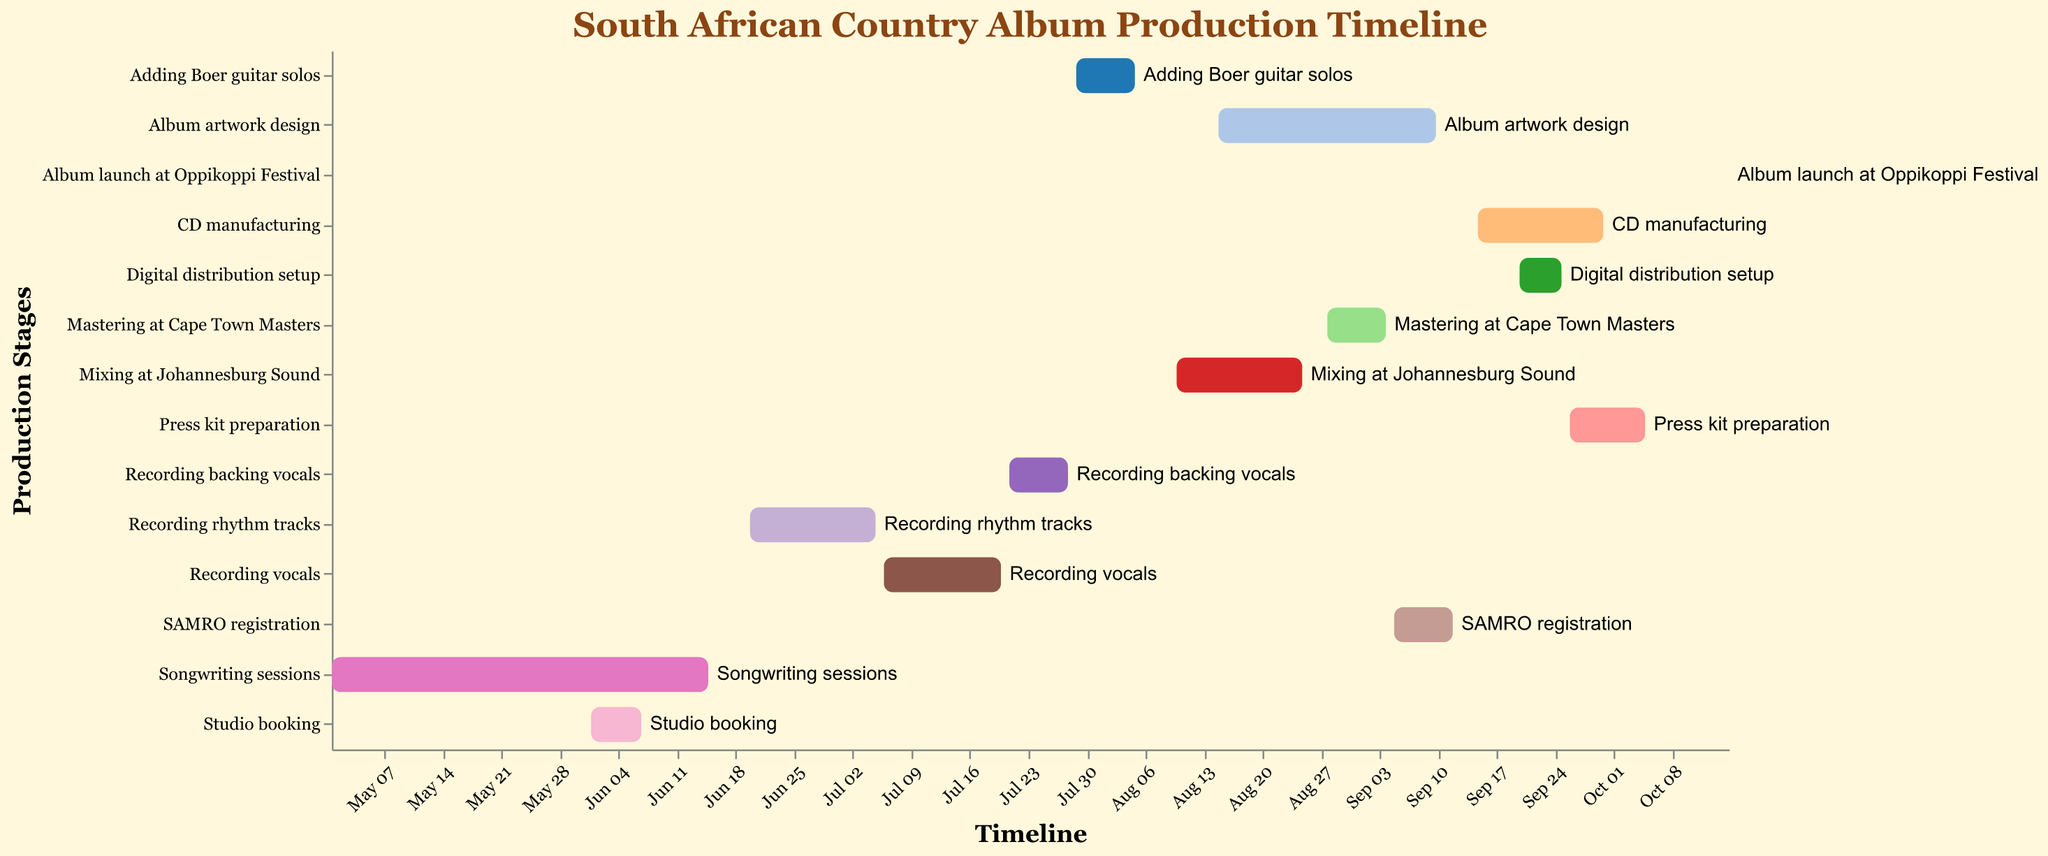What is the title of the Gantt Chart? The title of the chart is displayed at the top and provides a summary of the content. It helps the viewer quickly understand the focus of the figure. The title is "South African Country Album Production Timeline".
Answer: South African Country Album Production Timeline Which task spans the longest duration? To determine the task that spans the longest duration, we need to look at the start and end dates of each task and calculate the number of days for each. "Songwriting sessions" spans from May 1, 2023, to June 15, 2023, which is 45 days. The other tasks have shorter durations.
Answer: Songwriting sessions When does CD manufacturing start and end? Identify the "CD manufacturing" task on the y-axis and note the corresponding start and end dates on the x-axis. CD manufacturing starts on September 15, 2023, and ends on September 30, 2023, as indicated in the chart.
Answer: September 15, 2023 - September 30, 2023 Which tasks are completed before the start of "Recording rhythm tracks"? To find this out, check the end dates of all tasks and compare them with the start date of "Recording rhythm tracks" on June 20, 2023. The tasks that end before this date are "Songwriting sessions" (June 15, 2023) and "Studio booking" (June 7, 2023).
Answer: Songwriting sessions, Studio booking How long is the gap between the end of "Adding Boer guitar solos" and the start of "Mixing at Johannesburg Sound"? Determine the end date of "Adding Boer guitar solos" (August 5, 2023) and the start date of "Mixing at Johannesburg Sound" (August 10, 2023). Calculate the difference in days between these dates, which is 5 days.
Answer: 5 days Which tasks overlap with "Album artwork design"? Identify the start and end dates of "Album artwork design" (August 15, 2023 - September 10, 2023) and check for any other tasks that fall within this timeframe. The overlapping tasks are "Mixing at Johannesburg Sound", "Mastering at Cape Town Masters", and "SAMRO registration".
Answer: Mixing at Johannesburg Sound, Mastering at Cape Town Masters, SAMRO registration What is the last task before the album launch? To find the last task before the "Album launch at Oppikoppi Festival" on October 15, 2023, we look at the end dates of all tasks. The task that ends last before this date is "Press kit preparation" which ends on October 5, 2023.
Answer: Press kit preparation Which task has the shortest duration? Calculate the duration of each task by subtracting the start date from the end date. "Studio booking" is the shortest, lasting from June 1, 2023, to June 7, 2023, which is 6 days.
Answer: Studio booking What are the tasks involving recording, and when do they occur? Look for tasks with "Recording" in their names and note their start and end dates. The tasks are "Recording rhythm tracks" (June 20, 2023 - July 5, 2023), "Recording vocals" (July 6, 2023 - July 20, 2023), and "Recording backing vocals" (July 21, 2023 - July 28, 2023).
Answer: Recording rhythm tracks: June 20, 2023 - July 5, 2023, Recording vocals: July 6, 2023 - July 20, 2023, Recording backing vocals: July 21, 2023 - July 28, 2023 